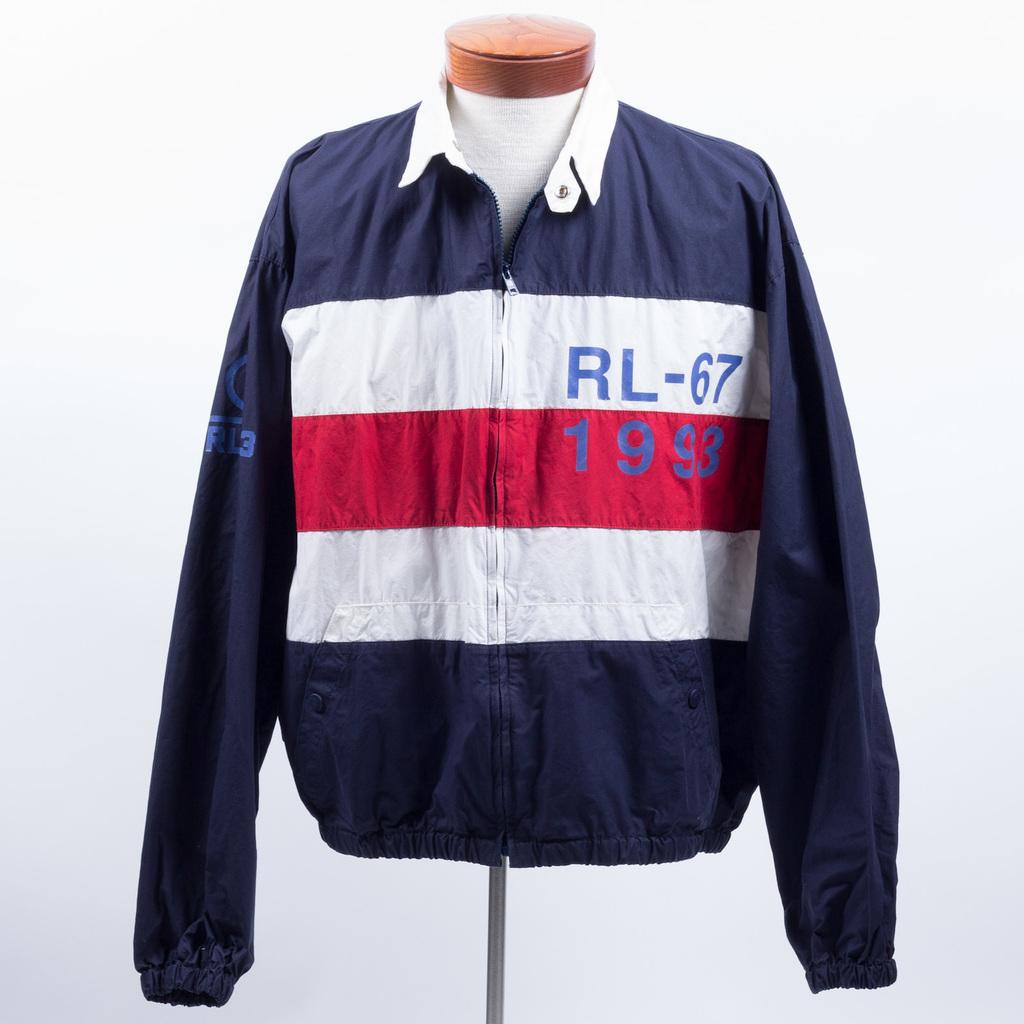What numbers are on the jacket?
Provide a succinct answer. 67 1993. 